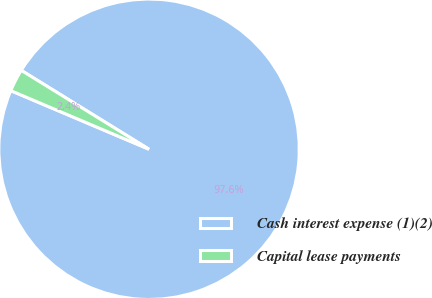Convert chart to OTSL. <chart><loc_0><loc_0><loc_500><loc_500><pie_chart><fcel>Cash interest expense (1)(2)<fcel>Capital lease payments<nl><fcel>97.58%<fcel>2.42%<nl></chart> 